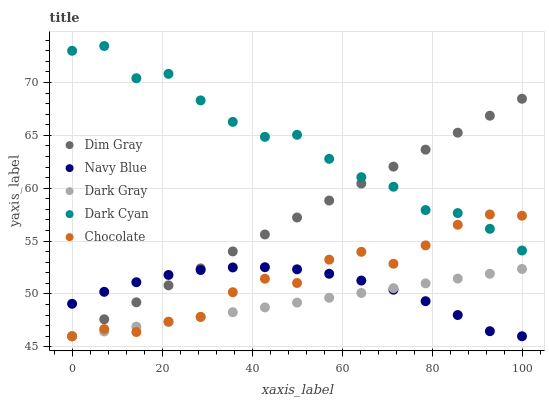Does Dark Gray have the minimum area under the curve?
Answer yes or no. Yes. Does Dark Cyan have the maximum area under the curve?
Answer yes or no. Yes. Does Navy Blue have the minimum area under the curve?
Answer yes or no. No. Does Navy Blue have the maximum area under the curve?
Answer yes or no. No. Is Dark Gray the smoothest?
Answer yes or no. Yes. Is Dark Cyan the roughest?
Answer yes or no. Yes. Is Navy Blue the smoothest?
Answer yes or no. No. Is Navy Blue the roughest?
Answer yes or no. No. Does Dark Gray have the lowest value?
Answer yes or no. Yes. Does Dark Cyan have the lowest value?
Answer yes or no. No. Does Dark Cyan have the highest value?
Answer yes or no. Yes. Does Navy Blue have the highest value?
Answer yes or no. No. Is Dark Gray less than Dark Cyan?
Answer yes or no. Yes. Is Dark Cyan greater than Navy Blue?
Answer yes or no. Yes. Does Dark Gray intersect Navy Blue?
Answer yes or no. Yes. Is Dark Gray less than Navy Blue?
Answer yes or no. No. Is Dark Gray greater than Navy Blue?
Answer yes or no. No. Does Dark Gray intersect Dark Cyan?
Answer yes or no. No. 